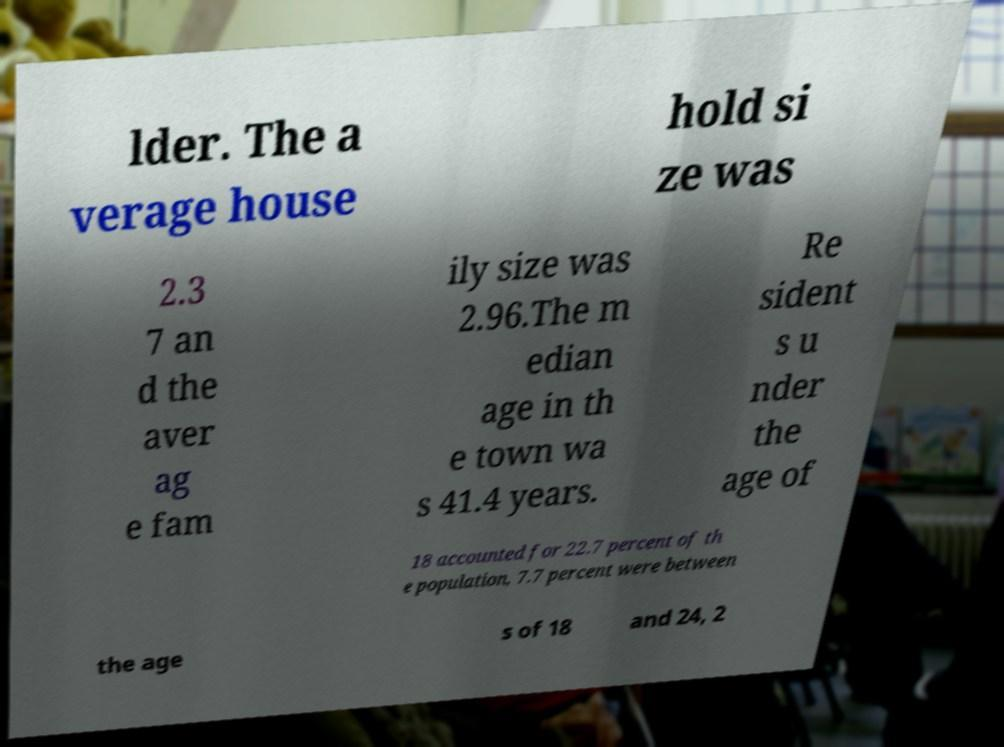Could you extract and type out the text from this image? lder. The a verage house hold si ze was 2.3 7 an d the aver ag e fam ily size was 2.96.The m edian age in th e town wa s 41.4 years. Re sident s u nder the age of 18 accounted for 22.7 percent of th e population, 7.7 percent were between the age s of 18 and 24, 2 